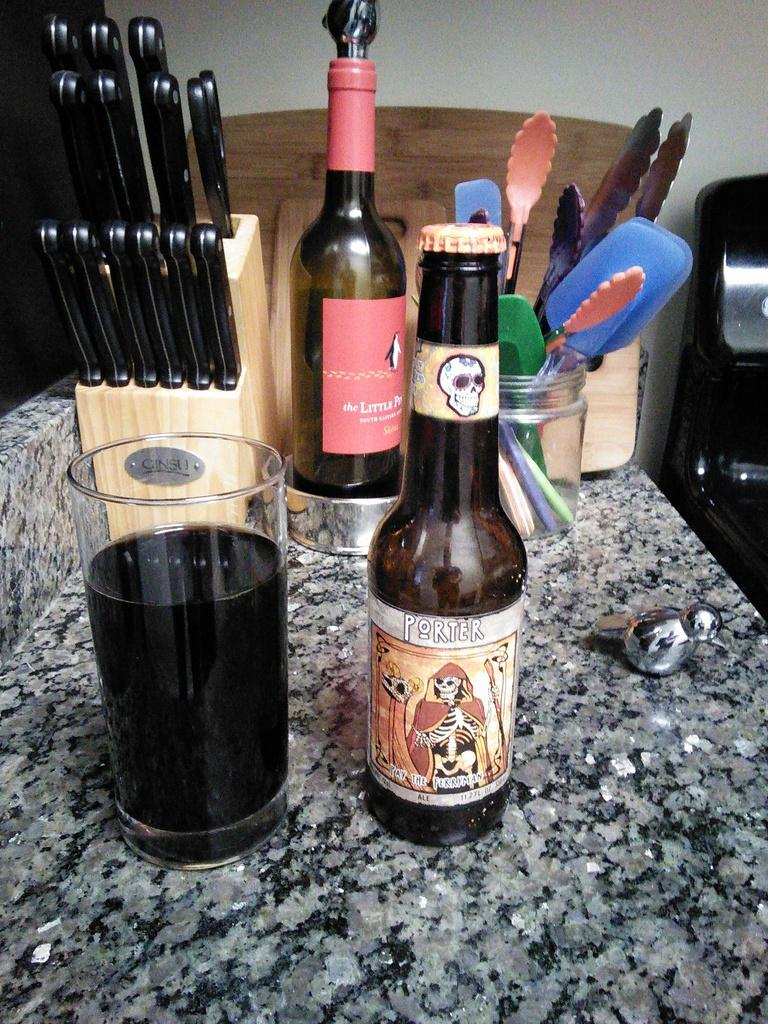Provide a one-sentence caption for the provided image. A brown bottle of Porter beer next to a tall tumble of beer. 